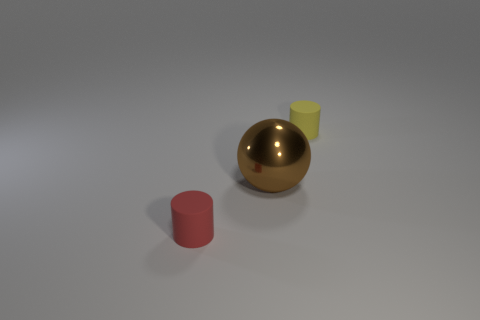Add 2 tiny red matte objects. How many objects exist? 5 Subtract all spheres. How many objects are left? 2 Subtract all small red matte cubes. Subtract all brown balls. How many objects are left? 2 Add 1 metallic spheres. How many metallic spheres are left? 2 Add 3 big green cylinders. How many big green cylinders exist? 3 Subtract 1 yellow cylinders. How many objects are left? 2 